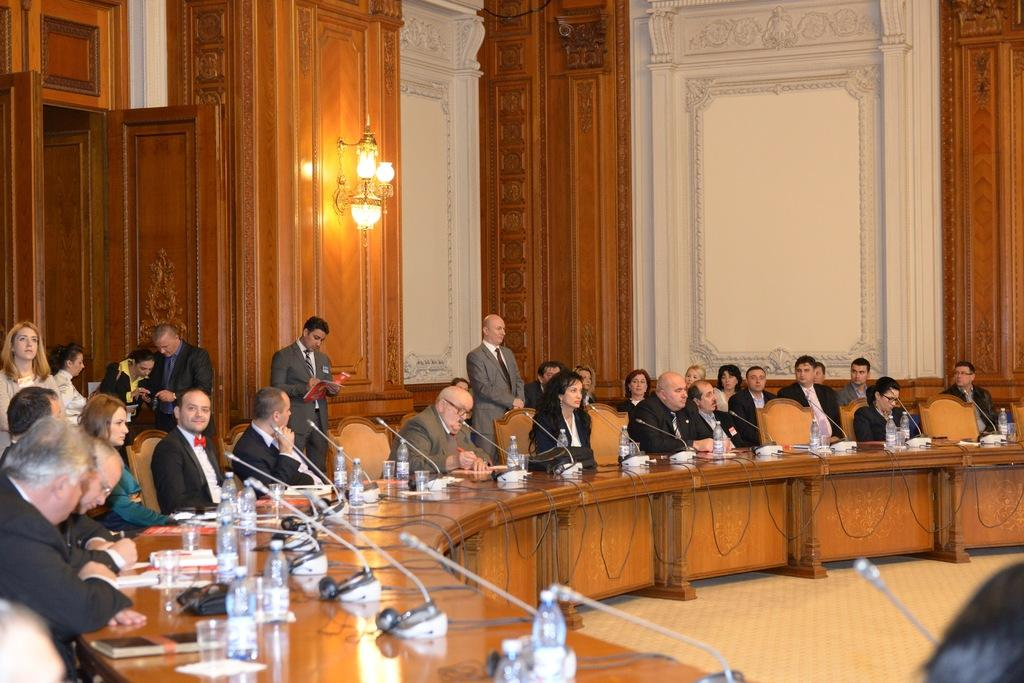What are the people in the image doing? There is a group of people sitting on chairs. What objects can be seen on the table in the image? There is a bottle, a microphone (mic), a glass, and a book on the table. Can you describe the lighting in the image? There is a light in the background. How many fish are swimming in the glass on the table? There are no fish present in the image; there is only a glass on the table. What is the size of the bath in the image? There is no bath present in the image. 